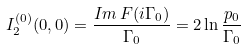Convert formula to latex. <formula><loc_0><loc_0><loc_500><loc_500>I ^ { ( 0 ) } _ { 2 } ( 0 , 0 ) = \frac { I m \, F ( i \Gamma _ { 0 } ) } { \Gamma _ { 0 } } = 2 \ln \frac { p _ { 0 } } { \Gamma _ { 0 } }</formula> 